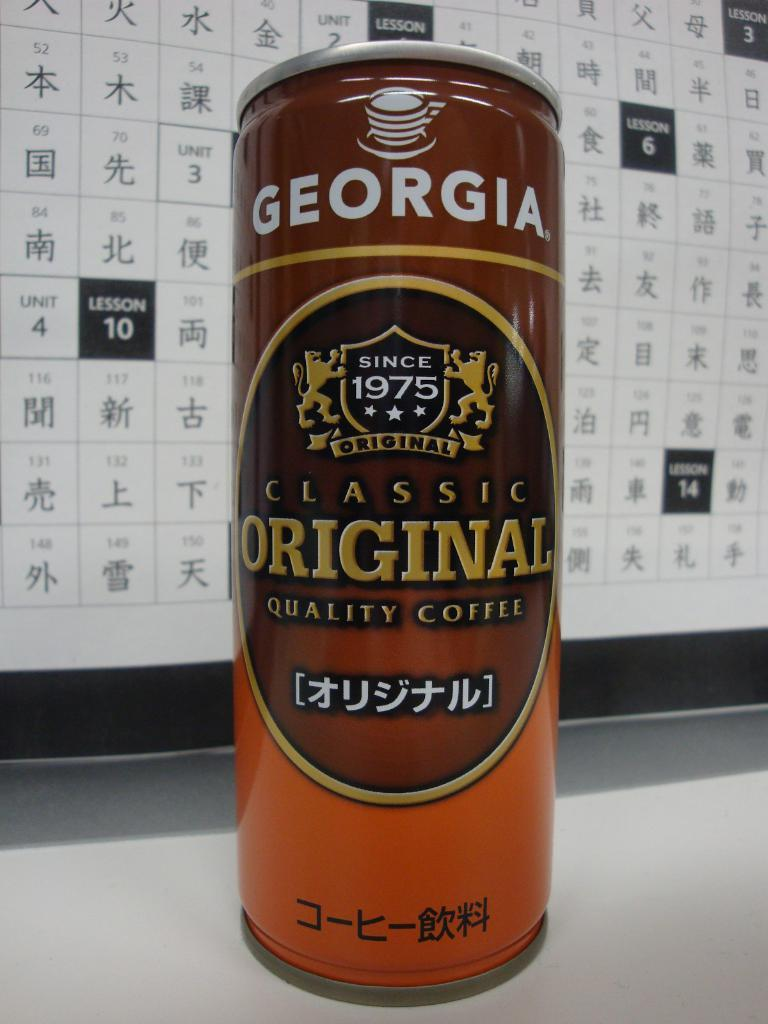<image>
Give a short and clear explanation of the subsequent image. An orange and brown can of coffee is in front of a Chinese calendar and is the flavor Classic Original. 